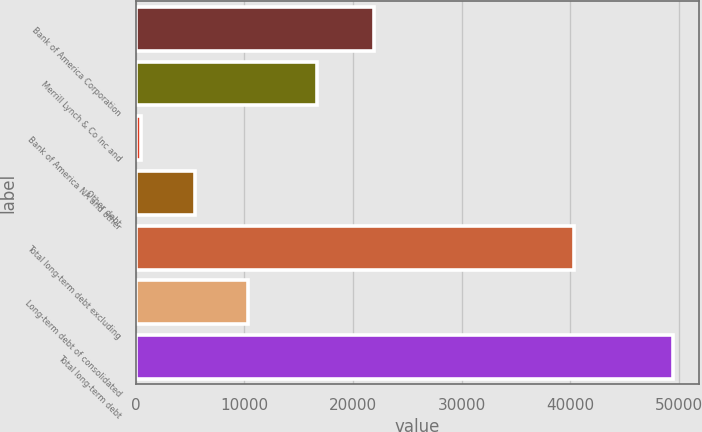<chart> <loc_0><loc_0><loc_500><loc_500><bar_chart><fcel>Bank of America Corporation<fcel>Merrill Lynch & Co Inc and<fcel>Bank of America NA and other<fcel>Other debt<fcel>Total long-term debt excluding<fcel>Long-term debt of consolidated<fcel>Total long-term debt<nl><fcel>21890<fcel>16650<fcel>503<fcel>5396.6<fcel>40336<fcel>10290.2<fcel>49439<nl></chart> 